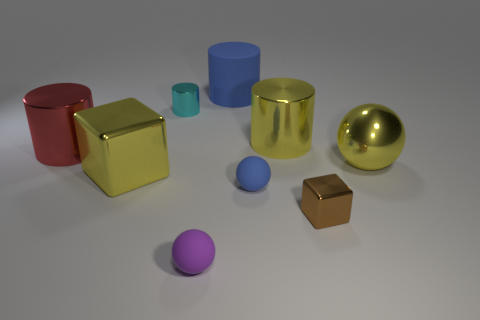There is a metallic thing that is the same shape as the small blue matte thing; what color is it?
Offer a very short reply. Yellow. There is a red metal object; is its shape the same as the rubber object that is behind the small cyan metal cylinder?
Offer a terse response. Yes. How many objects are blue objects that are behind the cyan metal object or cylinders in front of the large blue thing?
Give a very brief answer. 4. Are there fewer tiny blue objects that are on the left side of the tiny blue ball than cyan metal things?
Your answer should be very brief. Yes. Is the material of the small cyan thing the same as the cube that is on the right side of the rubber cylinder?
Give a very brief answer. Yes. What is the blue ball made of?
Your answer should be very brief. Rubber. What is the material of the big object to the right of the large metal cylinder that is on the right side of the big thing behind the small cyan cylinder?
Offer a very short reply. Metal. There is a big shiny ball; does it have the same color as the shiny cylinder that is on the left side of the tiny cyan cylinder?
Offer a very short reply. No. The small metal thing in front of the large red cylinder that is left of the large rubber cylinder is what color?
Make the answer very short. Brown. What number of tiny purple cylinders are there?
Offer a very short reply. 0. 